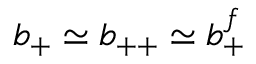<formula> <loc_0><loc_0><loc_500><loc_500>b _ { + } \simeq b _ { + + } \simeq b _ { + } ^ { f }</formula> 